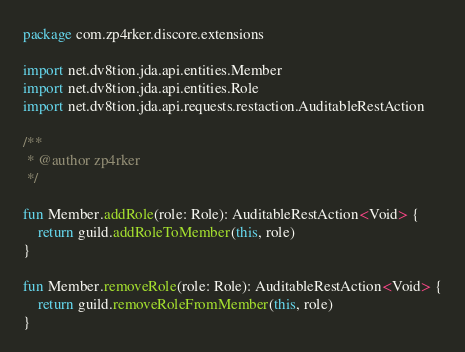Convert code to text. <code><loc_0><loc_0><loc_500><loc_500><_Kotlin_>package com.zp4rker.discore.extensions

import net.dv8tion.jda.api.entities.Member
import net.dv8tion.jda.api.entities.Role
import net.dv8tion.jda.api.requests.restaction.AuditableRestAction

/**
 * @author zp4rker
 */

fun Member.addRole(role: Role): AuditableRestAction<Void> {
    return guild.addRoleToMember(this, role)
}

fun Member.removeRole(role: Role): AuditableRestAction<Void> {
    return guild.removeRoleFromMember(this, role)
}</code> 